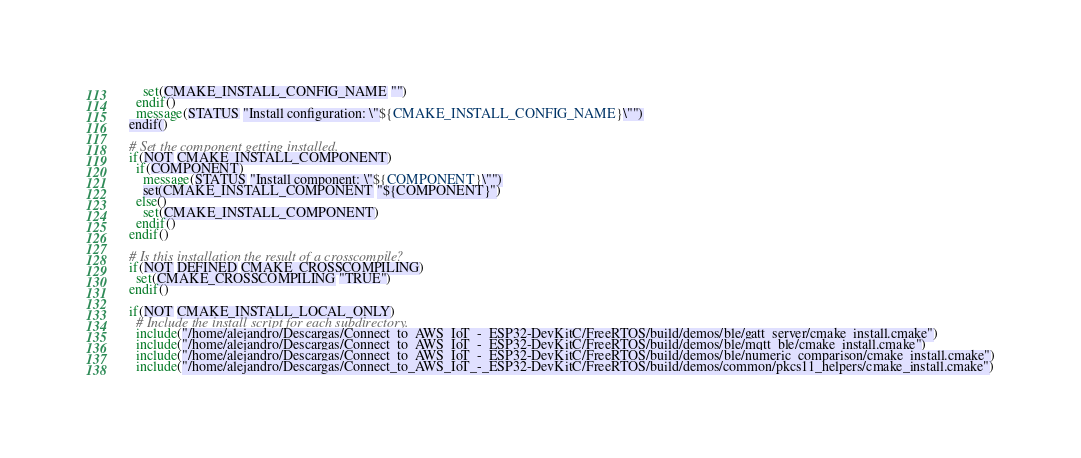<code> <loc_0><loc_0><loc_500><loc_500><_CMake_>    set(CMAKE_INSTALL_CONFIG_NAME "")
  endif()
  message(STATUS "Install configuration: \"${CMAKE_INSTALL_CONFIG_NAME}\"")
endif()

# Set the component getting installed.
if(NOT CMAKE_INSTALL_COMPONENT)
  if(COMPONENT)
    message(STATUS "Install component: \"${COMPONENT}\"")
    set(CMAKE_INSTALL_COMPONENT "${COMPONENT}")
  else()
    set(CMAKE_INSTALL_COMPONENT)
  endif()
endif()

# Is this installation the result of a crosscompile?
if(NOT DEFINED CMAKE_CROSSCOMPILING)
  set(CMAKE_CROSSCOMPILING "TRUE")
endif()

if(NOT CMAKE_INSTALL_LOCAL_ONLY)
  # Include the install script for each subdirectory.
  include("/home/alejandro/Descargas/Connect_to_AWS_IoT_-_ESP32-DevKitC/FreeRTOS/build/demos/ble/gatt_server/cmake_install.cmake")
  include("/home/alejandro/Descargas/Connect_to_AWS_IoT_-_ESP32-DevKitC/FreeRTOS/build/demos/ble/mqtt_ble/cmake_install.cmake")
  include("/home/alejandro/Descargas/Connect_to_AWS_IoT_-_ESP32-DevKitC/FreeRTOS/build/demos/ble/numeric_comparison/cmake_install.cmake")
  include("/home/alejandro/Descargas/Connect_to_AWS_IoT_-_ESP32-DevKitC/FreeRTOS/build/demos/common/pkcs11_helpers/cmake_install.cmake")</code> 